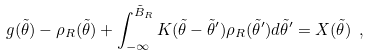Convert formula to latex. <formula><loc_0><loc_0><loc_500><loc_500>g ( \tilde { \theta } ) - \rho _ { R } ( \tilde { \theta } ) + \int _ { - \infty } ^ { \tilde { B } _ { R } } K ( \tilde { \theta } - \tilde { \theta } ^ { \prime } ) \rho _ { R } ( \tilde { \theta } ^ { \prime } ) d \tilde { \theta } ^ { \prime } = X ( \tilde { \theta } ) \ ,</formula> 